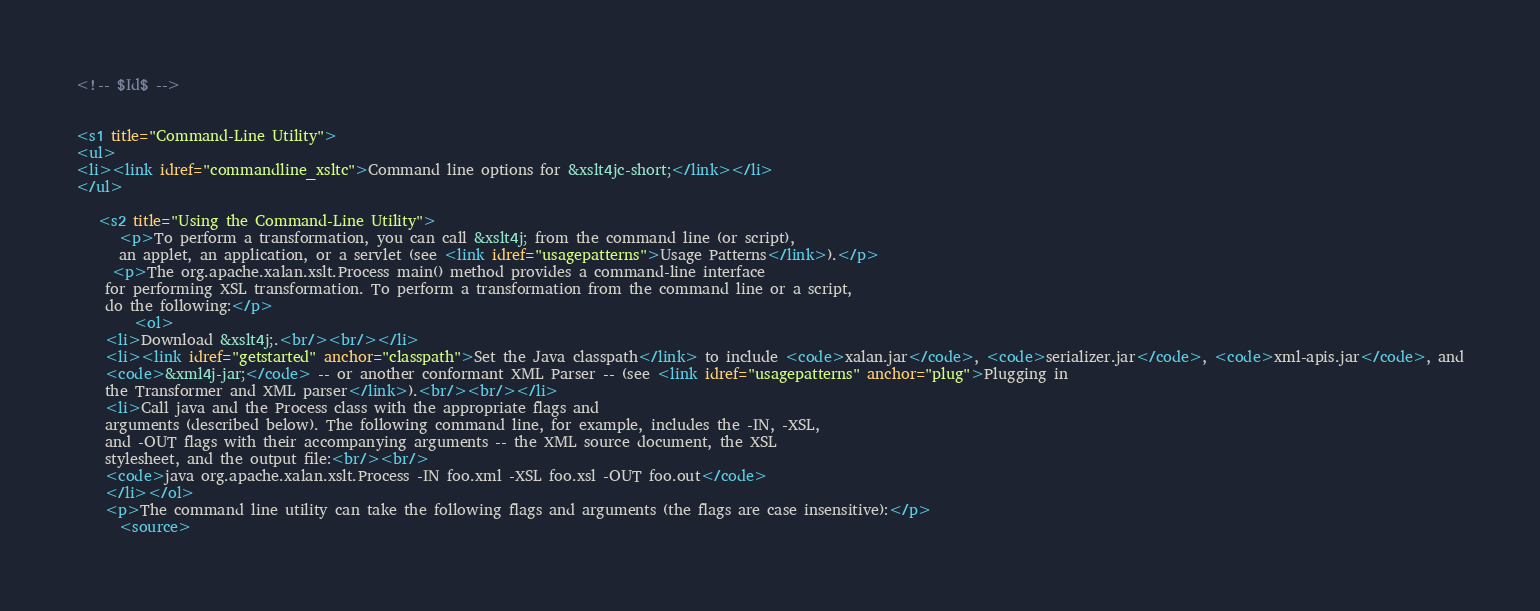Convert code to text. <code><loc_0><loc_0><loc_500><loc_500><_XML_><!-- $Id$ -->
 

<s1 title="Command-Line Utility">
<ul>
<li><link idref="commandline_xsltc">Command line options for &xslt4jc-short;</link></li>
</ul>
   
   <s2 title="Using the Command-Line Utility">
      <p>To perform a transformation, you can call &xslt4j; from the command line (or script), 
      an applet, an application, or a servlet (see <link idref="usagepatterns">Usage Patterns</link>).</p>
     <p>The org.apache.xalan.xslt.Process main() method provides a command-line interface
    for performing XSL transformation. To perform a transformation from the command line or a script,
    do the following:</p>
 		<ol>
    <li>Download &xslt4j;.<br/><br/></li> 
    <li><link idref="getstarted" anchor="classpath">Set the Java classpath</link> to include <code>xalan.jar</code>, <code>serializer.jar</code>, <code>xml-apis.jar</code>, and
    <code>&xml4j-jar;</code> -- or another conformant XML Parser -- (see <link idref="usagepatterns" anchor="plug">Plugging in 
    the Transformer and XML parser</link>).<br/><br/></li>
    <li>Call java and the Process class with the appropriate flags and
    arguments (described below). The following command line, for example, includes the -IN, -XSL,
    and -OUT flags with their accompanying arguments -- the XML source document, the XSL
    stylesheet, and the output file:<br/><br/>
    <code>java org.apache.xalan.xslt.Process -IN foo.xml -XSL foo.xsl -OUT foo.out</code>
    </li></ol>
    <p>The command line utility can take the following flags and arguments (the flags are case insensitive):</p> 
      <source></code> 